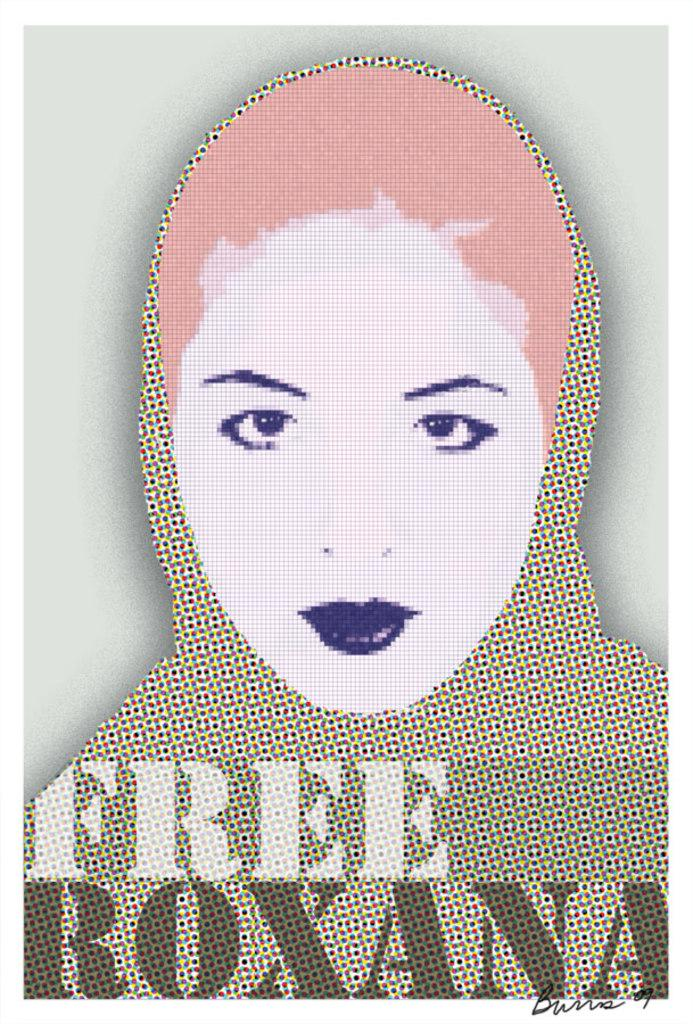What type of artwork is depicted in the image? The image is a digital painting. Can you describe the subject of the painting? There is a woman in the painting. Is there any text included in the image? Yes, there is text at the bottom of the image. What type of rock is being used to create sound in the image? There is no rock or sound being created in the image; it is a digital painting featuring a woman and text. 